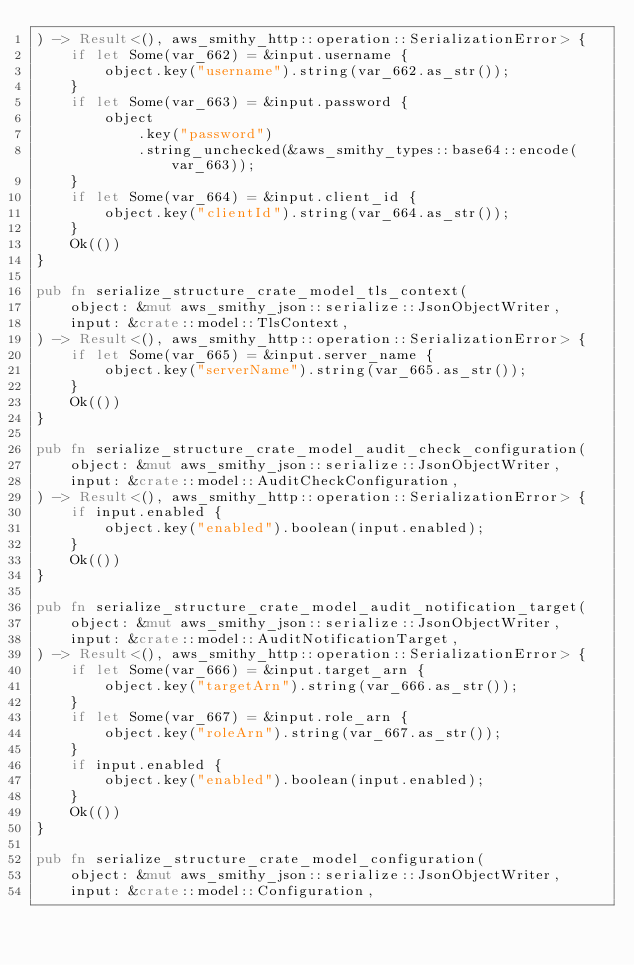Convert code to text. <code><loc_0><loc_0><loc_500><loc_500><_Rust_>) -> Result<(), aws_smithy_http::operation::SerializationError> {
    if let Some(var_662) = &input.username {
        object.key("username").string(var_662.as_str());
    }
    if let Some(var_663) = &input.password {
        object
            .key("password")
            .string_unchecked(&aws_smithy_types::base64::encode(var_663));
    }
    if let Some(var_664) = &input.client_id {
        object.key("clientId").string(var_664.as_str());
    }
    Ok(())
}

pub fn serialize_structure_crate_model_tls_context(
    object: &mut aws_smithy_json::serialize::JsonObjectWriter,
    input: &crate::model::TlsContext,
) -> Result<(), aws_smithy_http::operation::SerializationError> {
    if let Some(var_665) = &input.server_name {
        object.key("serverName").string(var_665.as_str());
    }
    Ok(())
}

pub fn serialize_structure_crate_model_audit_check_configuration(
    object: &mut aws_smithy_json::serialize::JsonObjectWriter,
    input: &crate::model::AuditCheckConfiguration,
) -> Result<(), aws_smithy_http::operation::SerializationError> {
    if input.enabled {
        object.key("enabled").boolean(input.enabled);
    }
    Ok(())
}

pub fn serialize_structure_crate_model_audit_notification_target(
    object: &mut aws_smithy_json::serialize::JsonObjectWriter,
    input: &crate::model::AuditNotificationTarget,
) -> Result<(), aws_smithy_http::operation::SerializationError> {
    if let Some(var_666) = &input.target_arn {
        object.key("targetArn").string(var_666.as_str());
    }
    if let Some(var_667) = &input.role_arn {
        object.key("roleArn").string(var_667.as_str());
    }
    if input.enabled {
        object.key("enabled").boolean(input.enabled);
    }
    Ok(())
}

pub fn serialize_structure_crate_model_configuration(
    object: &mut aws_smithy_json::serialize::JsonObjectWriter,
    input: &crate::model::Configuration,</code> 